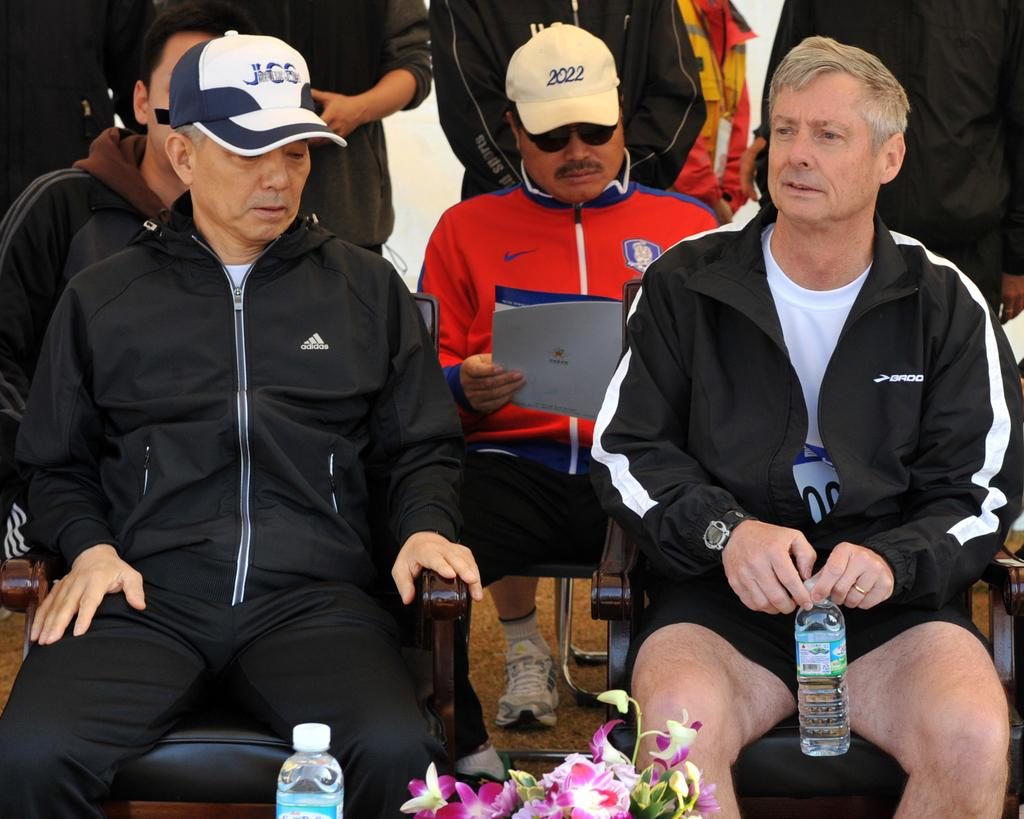Provide a one-sentence caption for the provided image. A man wearing a JCS hat sits in a track suit. 